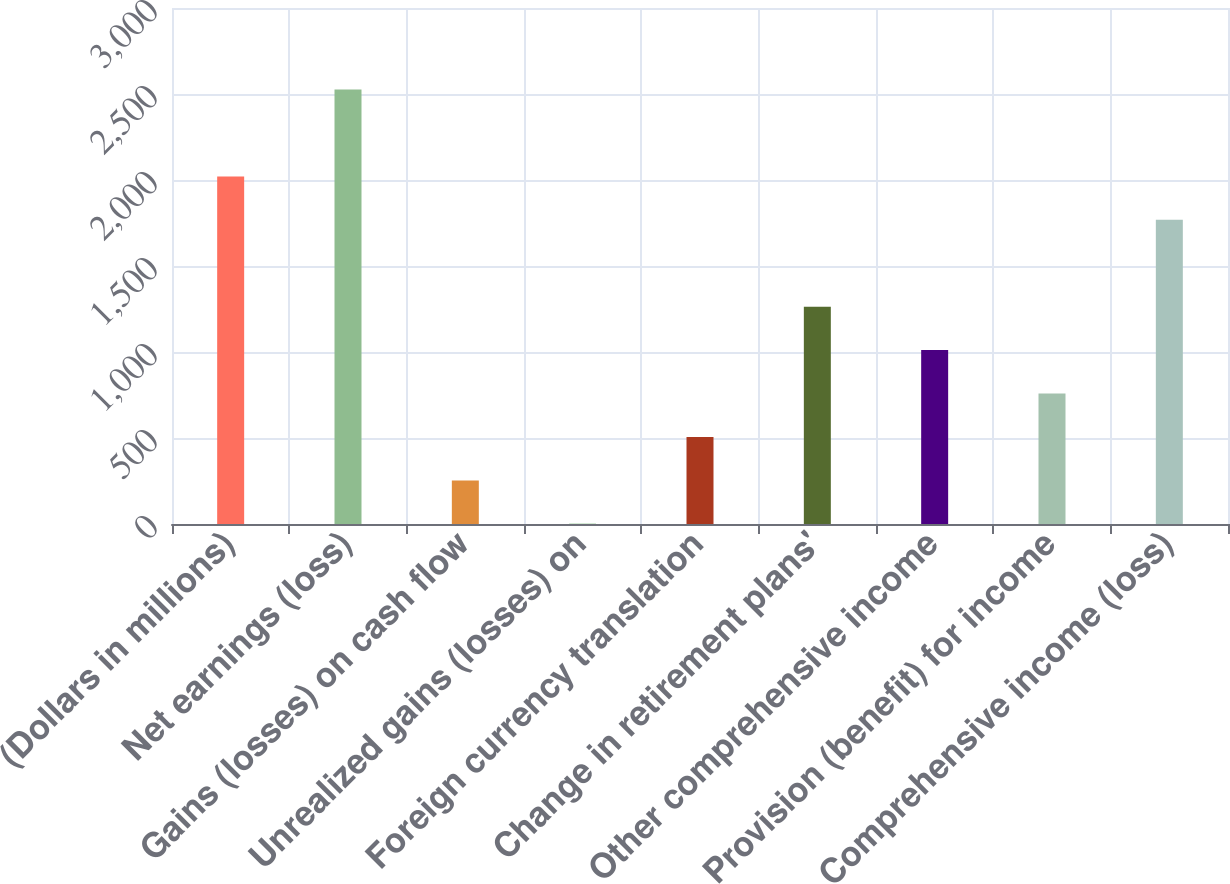<chart> <loc_0><loc_0><loc_500><loc_500><bar_chart><fcel>(Dollars in millions)<fcel>Net earnings (loss)<fcel>Gains (losses) on cash flow<fcel>Unrealized gains (losses) on<fcel>Foreign currency translation<fcel>Change in retirement plans'<fcel>Other comprehensive income<fcel>Provision (benefit) for income<fcel>Comprehensive income (loss)<nl><fcel>2021<fcel>2526<fcel>253.5<fcel>1<fcel>506<fcel>1263.5<fcel>1011<fcel>758.5<fcel>1768.5<nl></chart> 